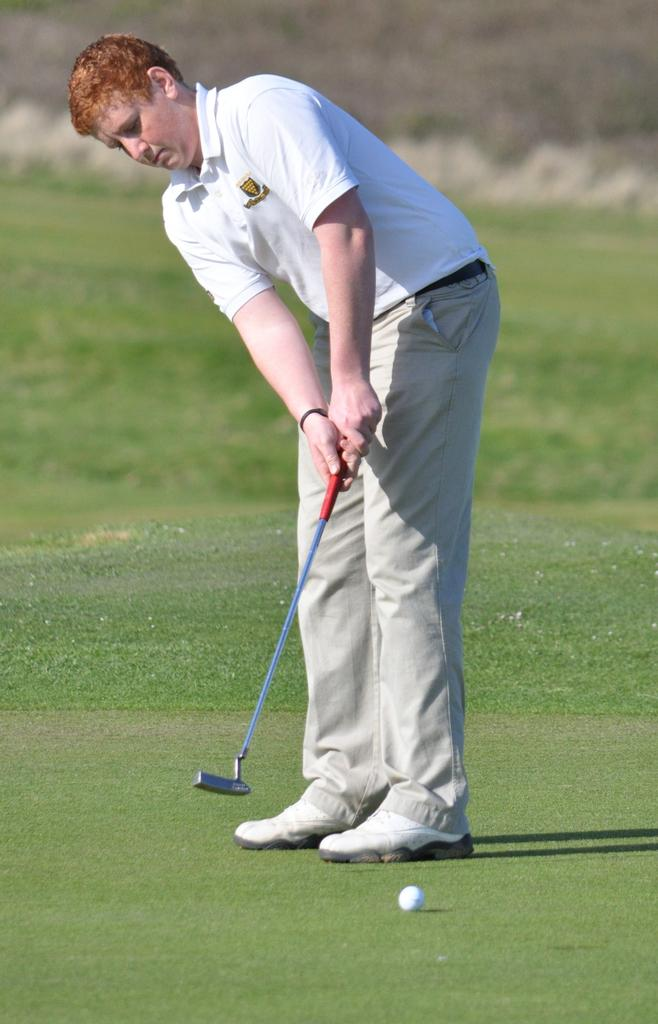Who or what is present in the image? There is a person in the image. What is the person holding in the image? The person is holding a bat. What is located at the bottom of the image? There is a ball at the bottom of the image. What color is the person's shirt in the image? The person is wearing a white shirt. What type of footwear is the person wearing in the image? The person is wearing shoes. What type of secretary is the person in the image? There is no indication in the image that the person is a secretary; they are holding a bat and wearing a white shirt and shoes. 